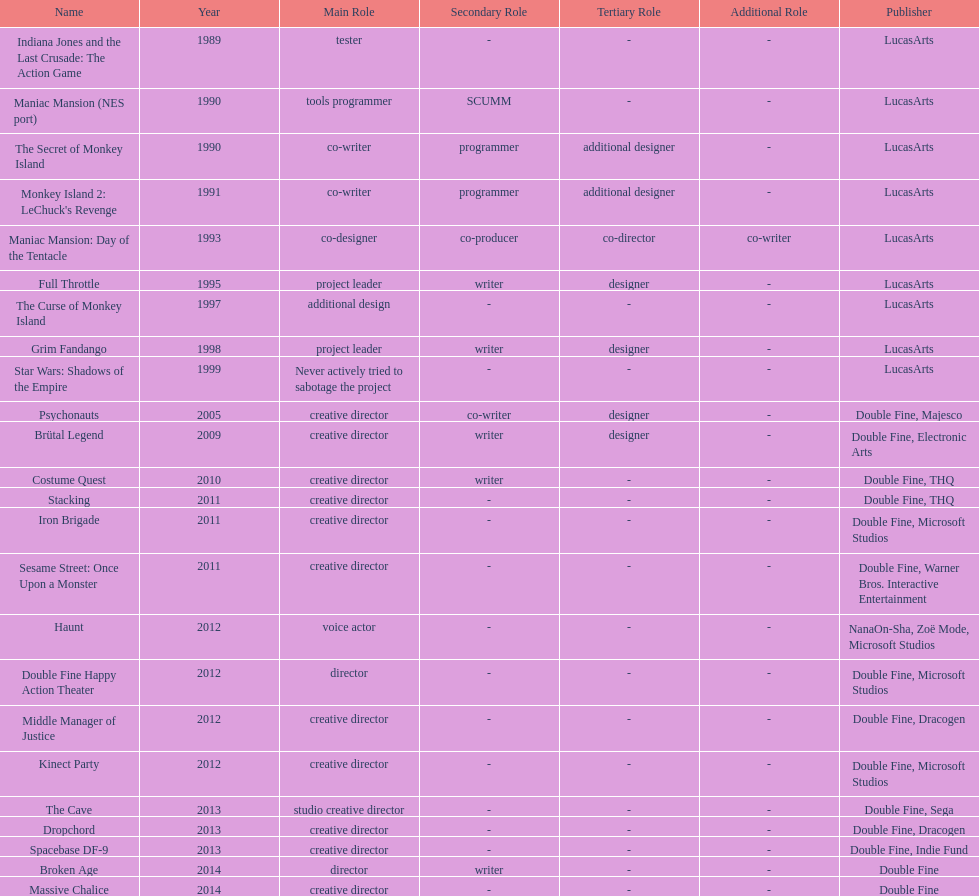Could you parse the entire table as a dict? {'header': ['Name', 'Year', 'Main Role', 'Secondary Role', 'Tertiary Role', 'Additional Role', 'Publisher'], 'rows': [['Indiana Jones and the Last Crusade: The Action Game', '1989', 'tester', '-', '-', '-', 'LucasArts'], ['Maniac Mansion (NES port)', '1990', 'tools programmer', 'SCUMM', '-', '-', 'LucasArts'], ['The Secret of Monkey Island', '1990', 'co-writer', 'programmer', 'additional designer', '-', 'LucasArts'], ["Monkey Island 2: LeChuck's Revenge", '1991', 'co-writer', 'programmer', 'additional designer', '-', 'LucasArts'], ['Maniac Mansion: Day of the Tentacle', '1993', 'co-designer', 'co-producer', 'co-director', 'co-writer', 'LucasArts'], ['Full Throttle', '1995', 'project leader', 'writer', 'designer', '-', 'LucasArts'], ['The Curse of Monkey Island', '1997', 'additional design', '-', '-', '-', 'LucasArts'], ['Grim Fandango', '1998', 'project leader', 'writer', 'designer', '-', 'LucasArts'], ['Star Wars: Shadows of the Empire', '1999', 'Never actively tried to sabotage the project', '-', '-', '-', 'LucasArts'], ['Psychonauts', '2005', 'creative director', 'co-writer', 'designer', '-', 'Double Fine, Majesco'], ['Brütal Legend', '2009', 'creative director', 'writer', 'designer', '-', 'Double Fine, Electronic Arts'], ['Costume Quest', '2010', 'creative director', 'writer', '-', '-', 'Double Fine, THQ'], ['Stacking', '2011', 'creative director', '-', '-', '-', 'Double Fine, THQ'], ['Iron Brigade', '2011', 'creative director', '-', '-', '-', 'Double Fine, Microsoft Studios'], ['Sesame Street: Once Upon a Monster', '2011', 'creative director', '-', '-', '-', 'Double Fine, Warner Bros. Interactive Entertainment'], ['Haunt', '2012', 'voice actor', '-', '-', '-', 'NanaOn-Sha, Zoë Mode, Microsoft Studios'], ['Double Fine Happy Action Theater', '2012', 'director', '-', '-', '-', 'Double Fine, Microsoft Studios'], ['Middle Manager of Justice', '2012', 'creative director', '-', '-', '-', 'Double Fine, Dracogen'], ['Kinect Party', '2012', 'creative director', '-', '-', '-', 'Double Fine, Microsoft Studios'], ['The Cave', '2013', 'studio creative director', '-', '-', '-', 'Double Fine, Sega'], ['Dropchord', '2013', 'creative director', '-', '-', '-', 'Double Fine, Dracogen'], ['Spacebase DF-9', '2013', 'creative director', '-', '-', '-', 'Double Fine, Indie Fund'], ['Broken Age', '2014', 'director', 'writer', '-', '-', 'Double Fine'], ['Massive Chalice', '2014', 'creative director', '-', '-', '-', 'Double Fine']]} How many games were credited with a creative director? 11. 